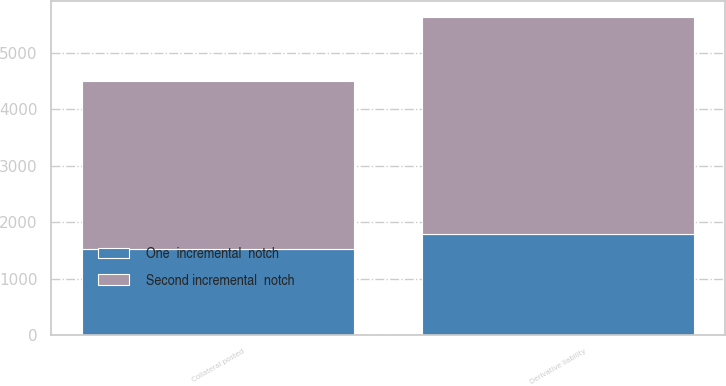Convert chart. <chart><loc_0><loc_0><loc_500><loc_500><stacked_bar_chart><ecel><fcel>Derivative liability<fcel>Collateral posted<nl><fcel>One  incremental  notch<fcel>1785<fcel>1520<nl><fcel>Second incremental  notch<fcel>3850<fcel>2986<nl></chart> 